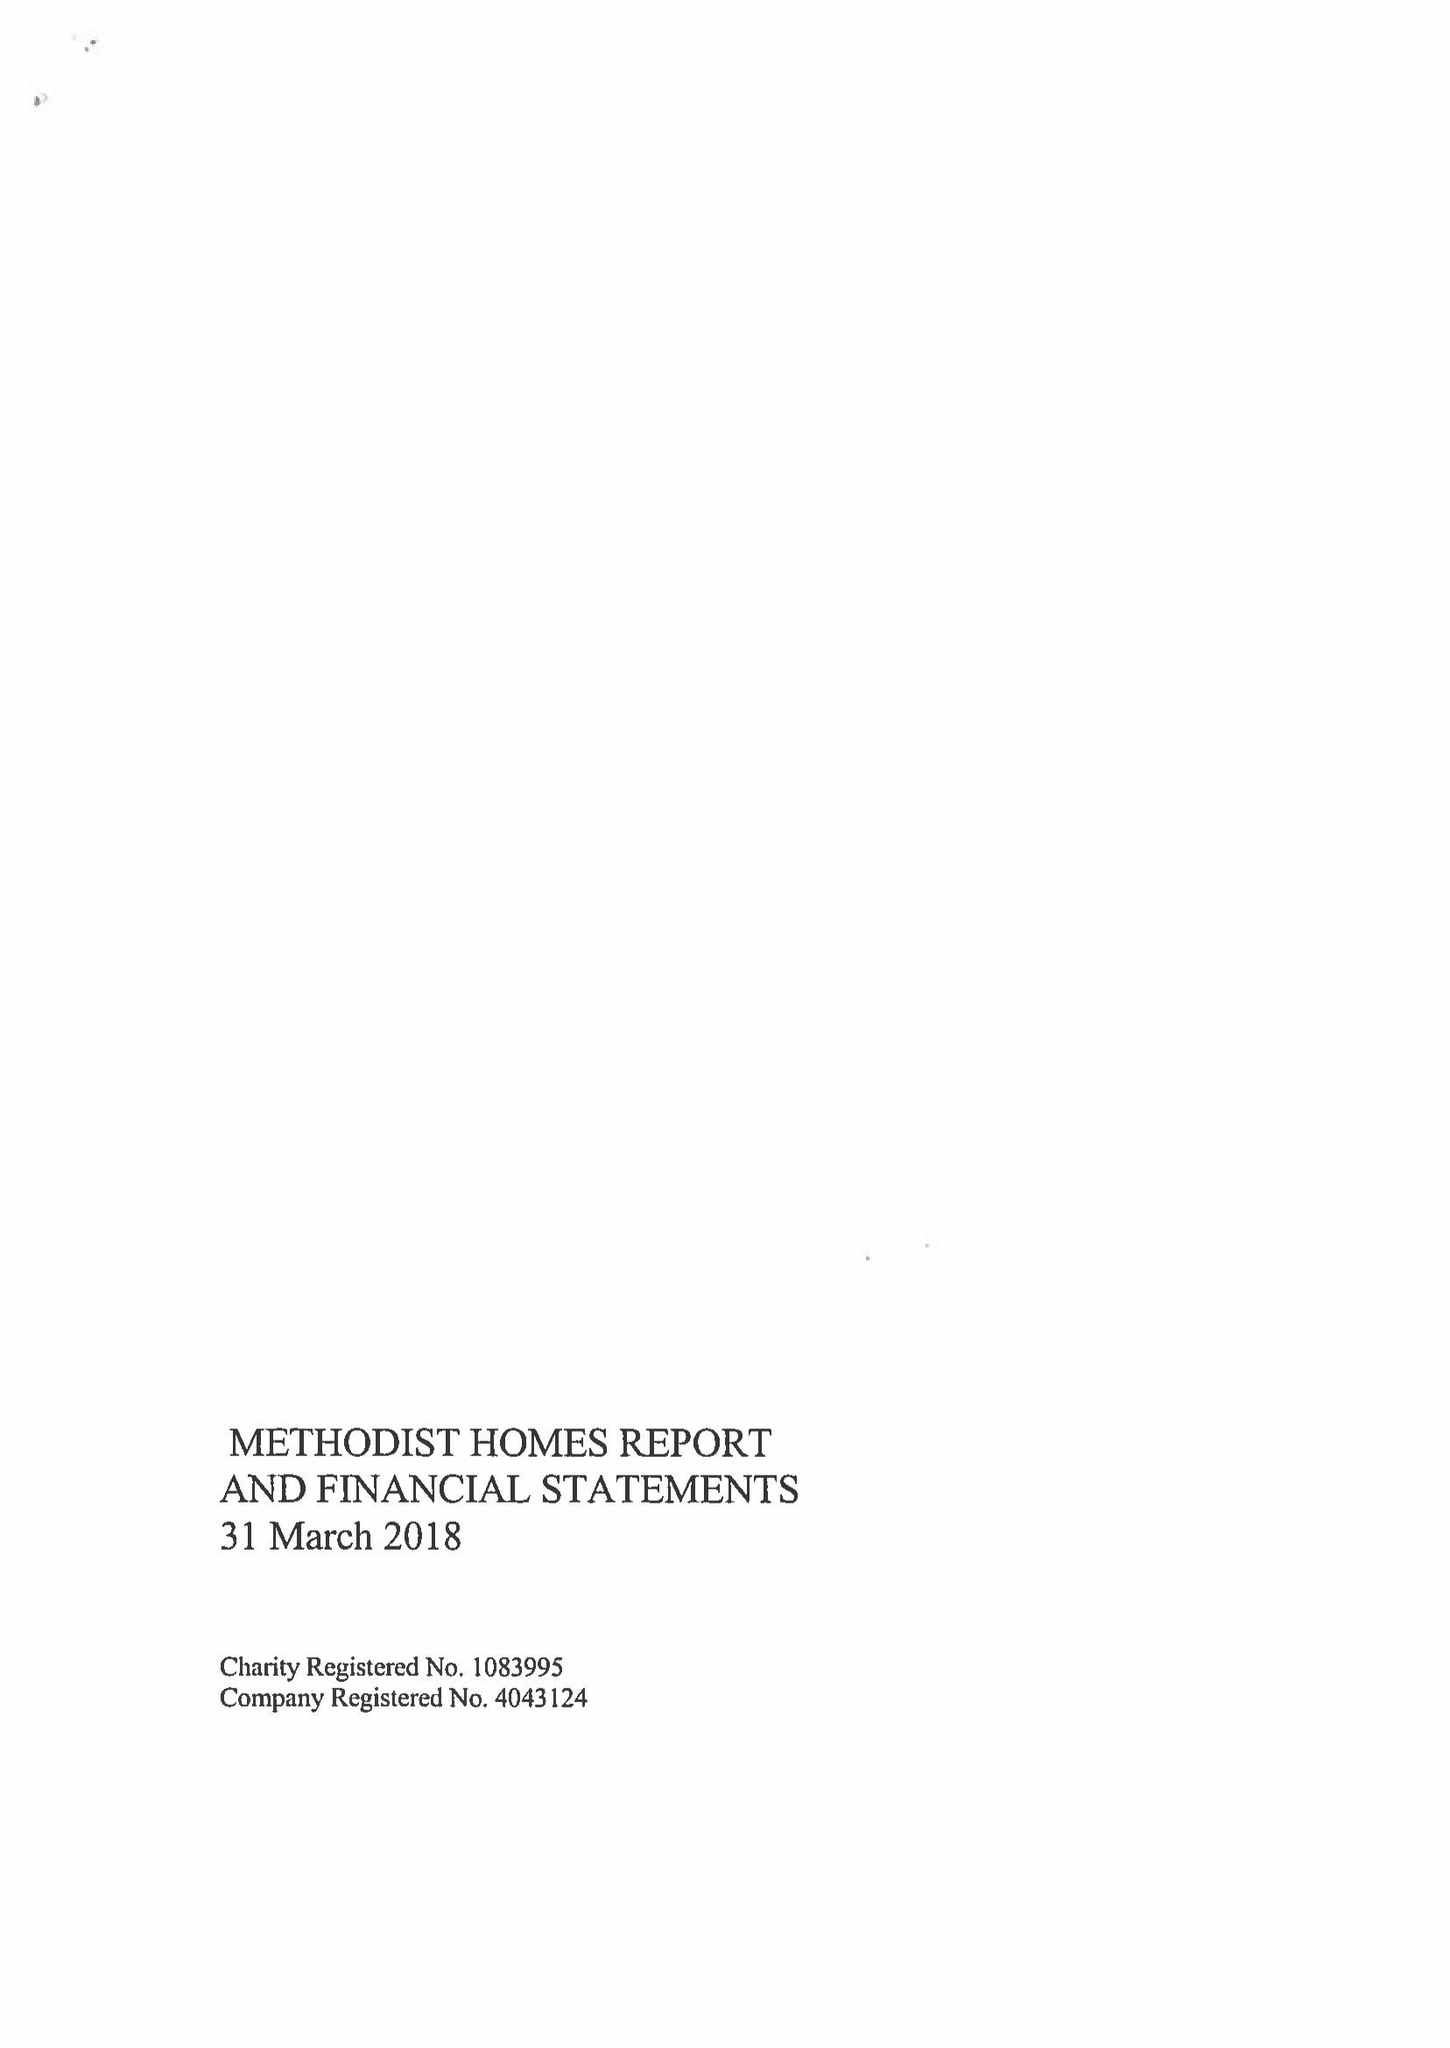What is the value for the charity_number?
Answer the question using a single word or phrase. 1083995 